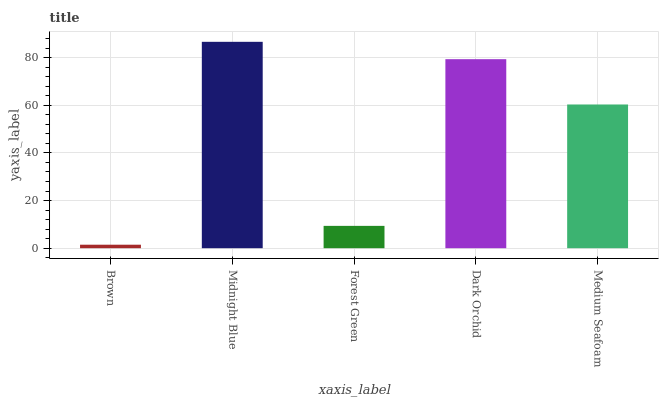Is Brown the minimum?
Answer yes or no. Yes. Is Midnight Blue the maximum?
Answer yes or no. Yes. Is Forest Green the minimum?
Answer yes or no. No. Is Forest Green the maximum?
Answer yes or no. No. Is Midnight Blue greater than Forest Green?
Answer yes or no. Yes. Is Forest Green less than Midnight Blue?
Answer yes or no. Yes. Is Forest Green greater than Midnight Blue?
Answer yes or no. No. Is Midnight Blue less than Forest Green?
Answer yes or no. No. Is Medium Seafoam the high median?
Answer yes or no. Yes. Is Medium Seafoam the low median?
Answer yes or no. Yes. Is Brown the high median?
Answer yes or no. No. Is Brown the low median?
Answer yes or no. No. 